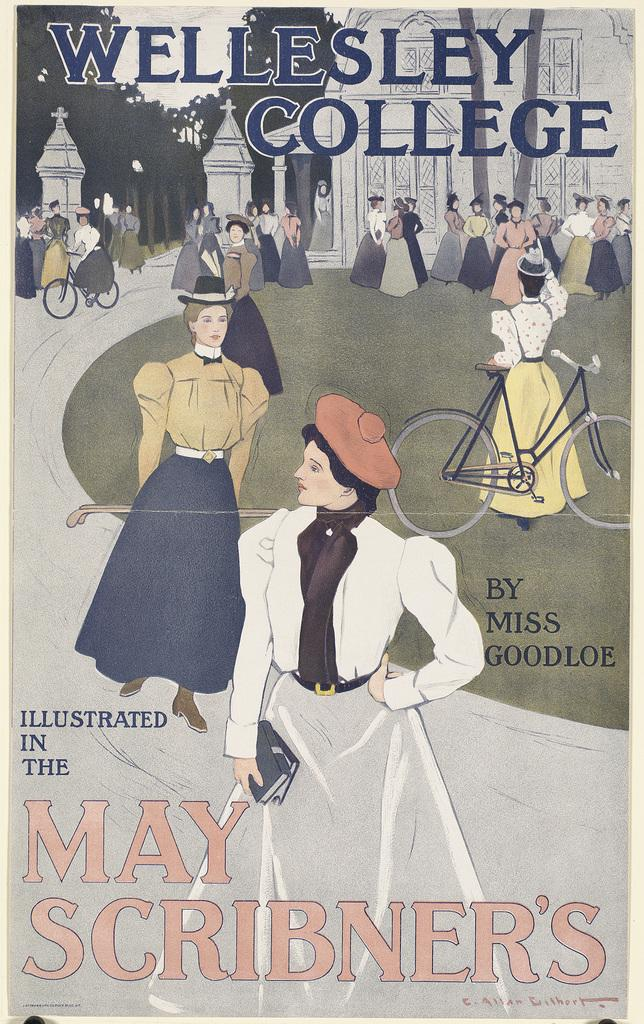<image>
Relay a brief, clear account of the picture shown. A poster (or magazine cover) shows a stylized scene from Wellesley College. 